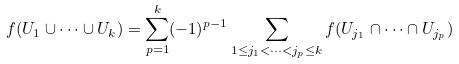<formula> <loc_0><loc_0><loc_500><loc_500>f ( U _ { 1 } \cup \dots \cup U _ { k } ) = \sum _ { p = 1 } ^ { k } ( - 1 ) ^ { p - 1 } \sum _ { 1 \leq j _ { 1 } < \dots < j _ { p } \leq k } f ( U _ { j _ { 1 } } \cap \dots \cap U _ { j _ { p } } )</formula> 